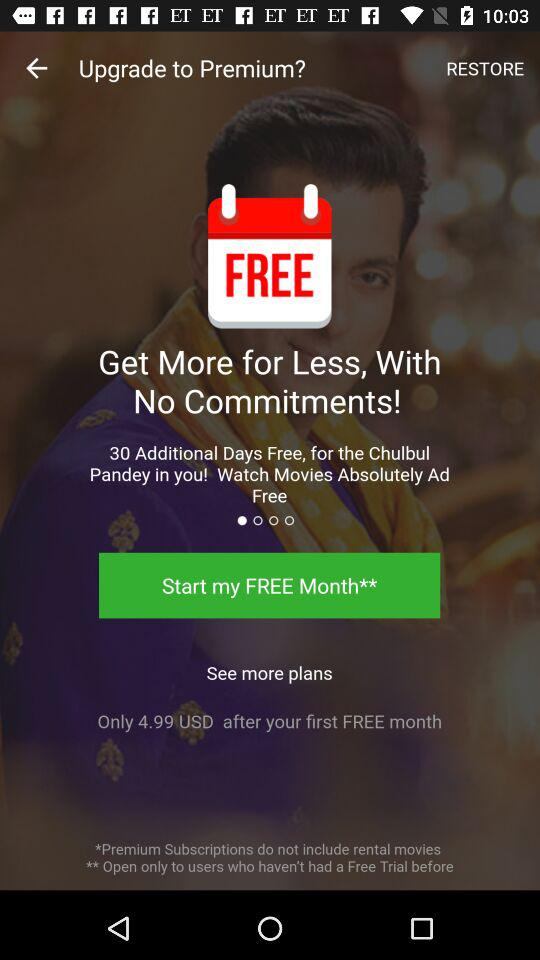How much will the user pay after the first free month? The user will pay 4.99 USD after the first free month. 